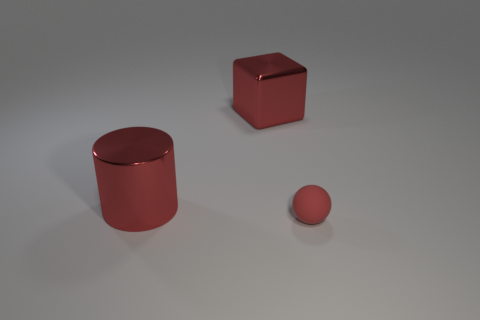What number of other objects are the same color as the tiny object?
Provide a succinct answer. 2. What material is the large red object that is in front of the shiny object behind the shiny thing on the left side of the red shiny cube?
Offer a very short reply. Metal. How many spheres are either tiny matte things or large red shiny objects?
Give a very brief answer. 1. Are there any other things that are the same size as the red metal cube?
Keep it short and to the point. Yes. There is a large object that is in front of the shiny object behind the big metal cylinder; what number of matte objects are to the right of it?
Provide a succinct answer. 1. Does the big object that is to the left of the large cube have the same material as the red thing that is to the right of the large red cube?
Offer a terse response. No. What number of things are red objects in front of the red metallic cube or things behind the tiny matte object?
Keep it short and to the point. 3. Is there anything else that has the same shape as the tiny rubber thing?
Offer a terse response. No. How many big red things are there?
Make the answer very short. 2. Is there a cyan cylinder that has the same size as the red cylinder?
Your answer should be very brief. No. 